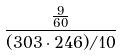Convert formula to latex. <formula><loc_0><loc_0><loc_500><loc_500>\frac { \frac { 9 } { 6 0 } } { ( 3 0 3 \cdot 2 4 6 ) / 1 0 }</formula> 